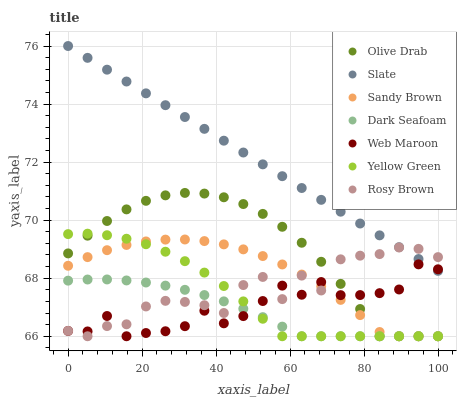Does Dark Seafoam have the minimum area under the curve?
Answer yes or no. Yes. Does Slate have the maximum area under the curve?
Answer yes or no. Yes. Does Rosy Brown have the minimum area under the curve?
Answer yes or no. No. Does Rosy Brown have the maximum area under the curve?
Answer yes or no. No. Is Slate the smoothest?
Answer yes or no. Yes. Is Rosy Brown the roughest?
Answer yes or no. Yes. Is Rosy Brown the smoothest?
Answer yes or no. No. Is Slate the roughest?
Answer yes or no. No. Does Yellow Green have the lowest value?
Answer yes or no. Yes. Does Slate have the lowest value?
Answer yes or no. No. Does Slate have the highest value?
Answer yes or no. Yes. Does Rosy Brown have the highest value?
Answer yes or no. No. Is Sandy Brown less than Slate?
Answer yes or no. Yes. Is Slate greater than Sandy Brown?
Answer yes or no. Yes. Does Sandy Brown intersect Yellow Green?
Answer yes or no. Yes. Is Sandy Brown less than Yellow Green?
Answer yes or no. No. Is Sandy Brown greater than Yellow Green?
Answer yes or no. No. Does Sandy Brown intersect Slate?
Answer yes or no. No. 